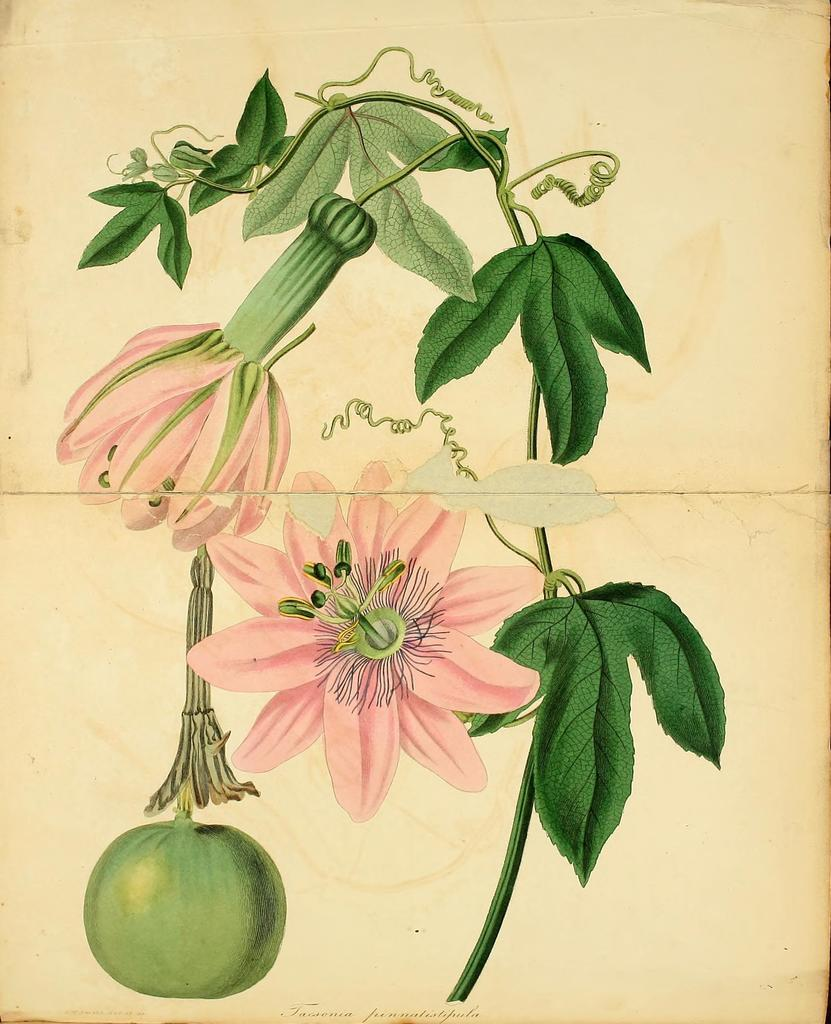What is present on the paper in the image? There is a paper in the image with words and various images. Can you describe the images on the paper? Yes, there are images of flowers, leaves, and a fruit or vegetable on the paper. How does the giraffe act in the image? There is no giraffe present in the image, so it cannot be determined how a giraffe might act. 